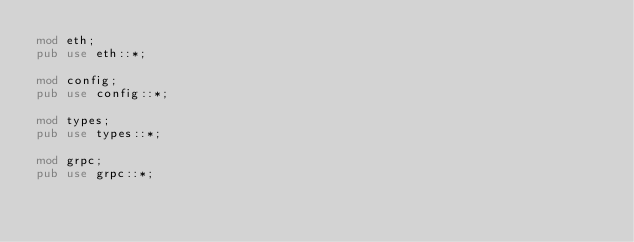<code> <loc_0><loc_0><loc_500><loc_500><_Rust_>mod eth;
pub use eth::*;

mod config;
pub use config::*;

mod types;
pub use types::*;

mod grpc;
pub use grpc::*;
</code> 